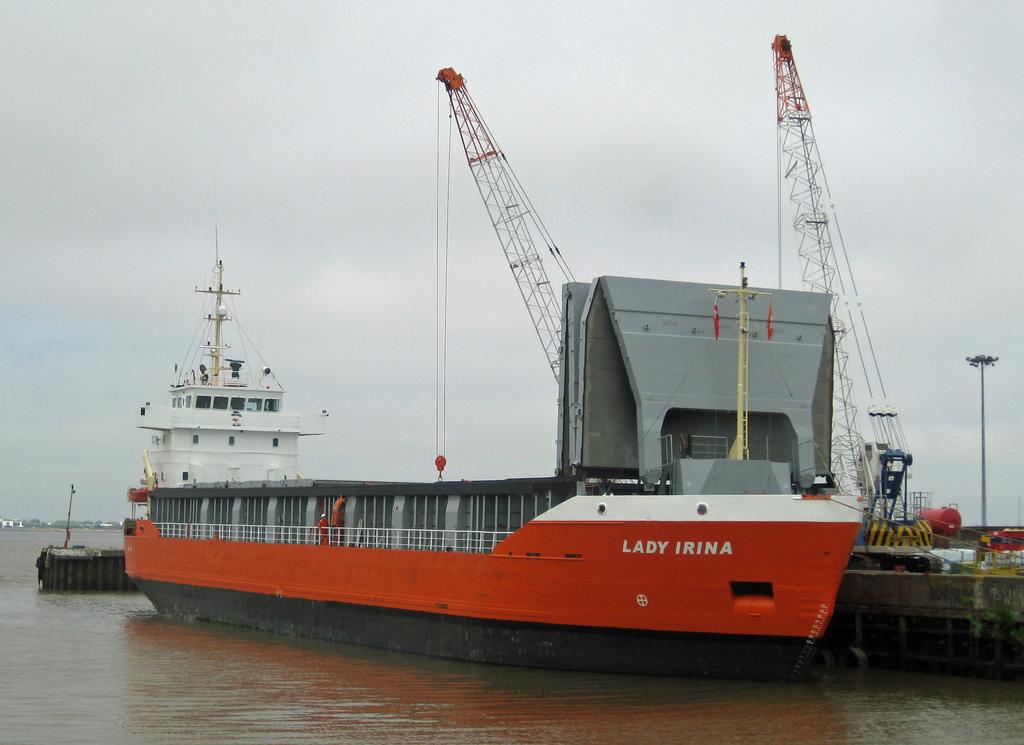What is the name of the boat?
Offer a terse response. Lady irina. 